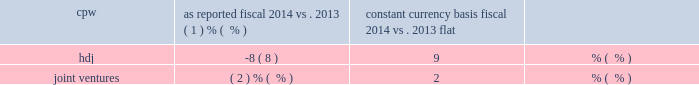22 general mills 2014 annual report 23 gross margin declined 1 percent in fiscal 2014 versus fiscal 2013 .
Gross margin as a percent of net sales of 36 percent was relatively flat compared to fiscal 2013 .
Selling , general and administrative ( sg&a ) expenses decreased $ 78 million in fiscal 2014 versus fiscal 2013 .
The decrease in sg&a expenses was primarily driven by a 3 percent decrease in advertising and media expense , a smaller contribution to the general mills foundation , a decrease in incentive compensation expense and lower pension expense compared to fiscal 2013 .
In fiscal 2014 , we recorded a $ 39 million charge related to venezuela currency devaluation compared to a $ 9 million charge in fiscal 2013 .
In addition , we recorded $ 12 million of inte- gration costs in fiscal 2013 related to our acquisition of yoki .
Sg&a expenses as a percent of net sales decreased 1 percent compared to fiscal 2013 .
Restructuring , impairment , and other exit costs totaled $ 4 million in fiscal 2014 .
The restructuring charge related to a productivity and cost savings plan approved in the fourth quarter of fiscal 2012 .
These restructuring actions were completed in fiscal 2014 .
In fiscal 2014 , we paid $ 22 million in cash related to restructuring actions .
During fiscal 2014 , we recorded a divestiture gain of $ 66 million related to the sale of certain grain elevators in our u.s .
Retail segment .
There were no divestitures in fiscal 2013 .
Interest , net for fiscal 2014 totaled $ 302 million , $ 15 million lower than fiscal 2013 .
The average interest rate decreased 41 basis points , including the effect of the mix of debt , generating a $ 31 million decrease in net interest .
Average interest bearing instruments increased $ 367 million , generating a $ 16 million increase in net interest .
Our consolidated effective tax rate for fiscal 2014 was 33.3 percent compared to 29.2 percent in fiscal 2013 .
The 4.1 percentage point increase was primarily related to the restructuring of our general mills cereals , llc ( gmc ) subsidiary during the first quarter of 2013 which resulted in a $ 63 million decrease to deferred income tax liabilities related to the tax basis of the investment in gmc and certain distributed assets , with a correspond- ing non-cash reduction to income taxes .
During fiscal 2013 , we also recorded a $ 34 million discrete decrease in income tax expense and an increase in our deferred tax assets related to certain actions taken to restore part of the tax benefits associated with medicare part d subsidies which had previously been reduced in fiscal 2010 with the enactment of the patient protection and affordable care act , as amended by the health care and education reconciliation act of 2010 .
Our fiscal 2013 tax expense also includes a $ 12 million charge associated with the liquidation of a corporate investment .
After-tax earnings from joint ventures for fiscal 2014 decreased to $ 90 million compared to $ 99 million in fiscal 2013 primarily driven by increased consumer spending at cereal partners worldwide ( cpw ) and unfavorable foreign currency exchange from h e4agen- dazs japan , inc .
( hdj ) .
The change in net sales for each joint venture is set forth in the table : joint venture change in net sales as reported constant currency basis fiscal 2014 fiscal 2014 vs .
2013 vs .
2013 cpw ( 1 ) % (  % ) flat .
In fiscal 2014 , cpw net sales declined by 1 percent- age point due to unfavorable foreign currency exchange .
Contribution from volume growth was flat compared to fiscal 2013 .
In fiscal 2014 , net sales for hdj decreased 8 percentage points from fiscal 2013 as 11 percentage points of contributions from volume growth was offset by 17 percentage points of net sales decline from unfa- vorable foreign currency exchange and 2 percentage points of net sales decline attributable to unfavorable net price realization and mix .
Average diluted shares outstanding decreased by 20 million in fiscal 2014 from fiscal 2013 due primar- ily to the repurchase of 36 million shares , partially offset by the issuance of 7 million shares related to stock compensation plans .
Fiscal 2014 consolidated balance sheet analysis cash and cash equivalents increased $ 126 million from fiscal 2013 .
Receivables increased $ 37 million from fiscal 2013 pri- marily driven by timing of sales .
Inventories increased $ 14 million from fiscal 2013 .
Prepaid expenses and other current assets decreased $ 29 million from fiscal 2013 , mainly due to a decrease in other receivables related to the liquidation of a corporate investment .
Land , buildings , and equipment increased $ 64 million from fiscal 2013 , as $ 664 million of capital expenditures .
What was the percent of the reduction in the after-tax earnings from joint ventures primarily driven by increased consumer spending at cereal partners worldwide ( cpw ) and unfavorable foreign currency exchange from h e4agen- dazs japan , inc . from 2012 to 2013? 
Computations: ((90 - 99) / 99)
Answer: -0.09091. 